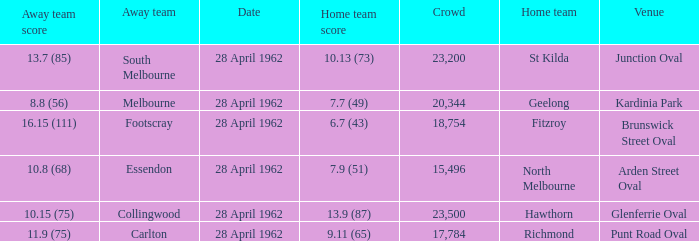At what venue did an away team score 10.15 (75)? Glenferrie Oval. 